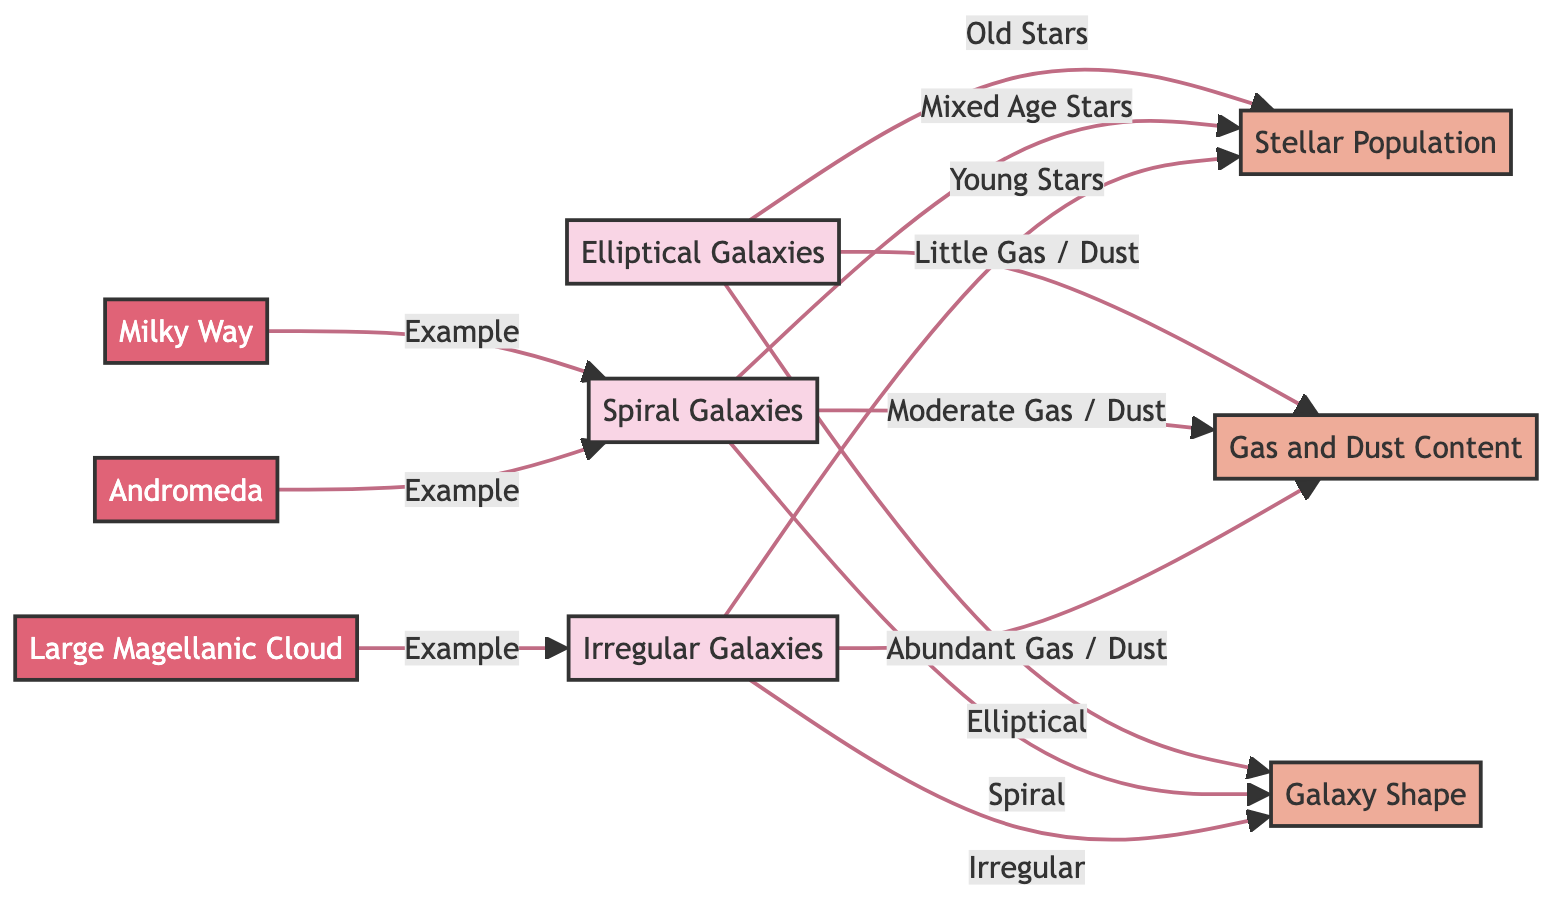What types of galaxies are represented in the diagram? The diagram displays three types of galaxies: Elliptical, Spiral, and Irregular. These are explicitly listed as nodes in the diagram.
Answer: Elliptical, Spiral, Irregular How many characteristics are associated with the different galaxy types? The diagram depicts three characteristics that are linked to the types of galaxies: Stellar Population, Gas and Dust Content, and Galaxy Shape. Thus, we can count them directly from the diagram.
Answer: 3 What type of stars are primarily found in Elliptical Galaxies? According to the diagram, Elliptical Galaxies are associated with old stars, which is the specific relationship indicated in the flowchart.
Answer: Old Stars Which galaxy type has abundant gas and dust content? The Irregular Galaxies are connected in the diagram to having abundant gas and dust content, as the relationship is directly stated in the flowchart.
Answer: Irregular Galaxies What is the shape characteristic of Spiral Galaxies? Spiral Galaxies are described in the diagram to have a spiral shape as their defining characteristic, which is clearly outlined in the relationships presented.
Answer: Spiral Which galaxy is listed as an example of a Spiral Galaxy? The Milky Way and Andromeda are both mentioned as examples of Spiral Galaxies within the diagram. We can identify these by their specific linkages to the Spiral Galaxies node.
Answer: Milky Way, Andromeda What relationship does Gas and Dust Content have with Elliptical Galaxies? The diagram states that Elliptical Galaxies have little gas and dust, emphasizing the direct correlation indicated between these entities.
Answer: Little Gas / Dust How are young stars related to Irregular Galaxies? The diagram indicates that Irregular Galaxies are characterized by having young stars, which is a relationship depicted directly in the flowchart.
Answer: Young Stars 